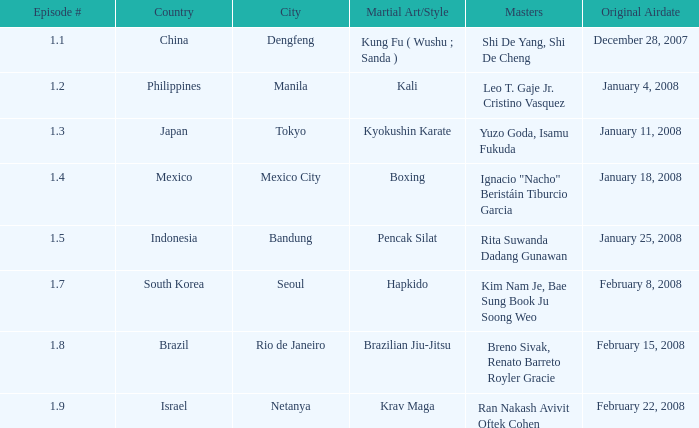Which form of martial arts was exhibited in rio de janeiro? Brazilian Jiu-Jitsu. Could you parse the entire table? {'header': ['Episode #', 'Country', 'City', 'Martial Art/Style', 'Masters', 'Original Airdate'], 'rows': [['1.1', 'China', 'Dengfeng', 'Kung Fu ( Wushu ; Sanda )', 'Shi De Yang, Shi De Cheng', 'December 28, 2007'], ['1.2', 'Philippines', 'Manila', 'Kali', 'Leo T. Gaje Jr. Cristino Vasquez', 'January 4, 2008'], ['1.3', 'Japan', 'Tokyo', 'Kyokushin Karate', 'Yuzo Goda, Isamu Fukuda', 'January 11, 2008'], ['1.4', 'Mexico', 'Mexico City', 'Boxing', 'Ignacio "Nacho" Beristáin Tiburcio Garcia', 'January 18, 2008'], ['1.5', 'Indonesia', 'Bandung', 'Pencak Silat', 'Rita Suwanda Dadang Gunawan', 'January 25, 2008'], ['1.7', 'South Korea', 'Seoul', 'Hapkido', 'Kim Nam Je, Bae Sung Book Ju Soong Weo', 'February 8, 2008'], ['1.8', 'Brazil', 'Rio de Janeiro', 'Brazilian Jiu-Jitsu', 'Breno Sivak, Renato Barreto Royler Gracie', 'February 15, 2008'], ['1.9', 'Israel', 'Netanya', 'Krav Maga', 'Ran Nakash Avivit Oftek Cohen', 'February 22, 2008']]} 